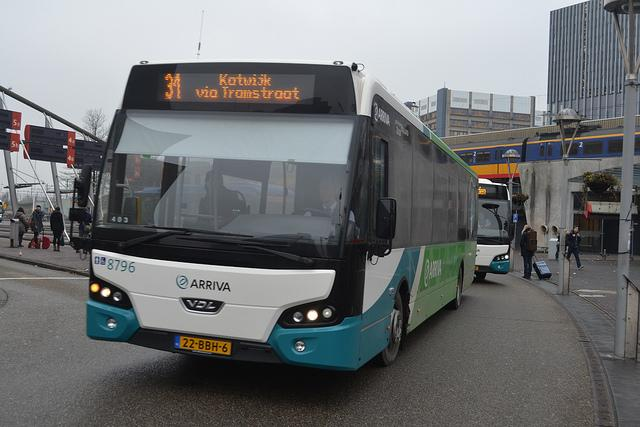Which animal would weigh more than this vehicle if it had no passengers? Please explain your reasoning. diplodocus. This is a guess since the animal is currently extinct. that said, the other options don't seem like they would weight more. 